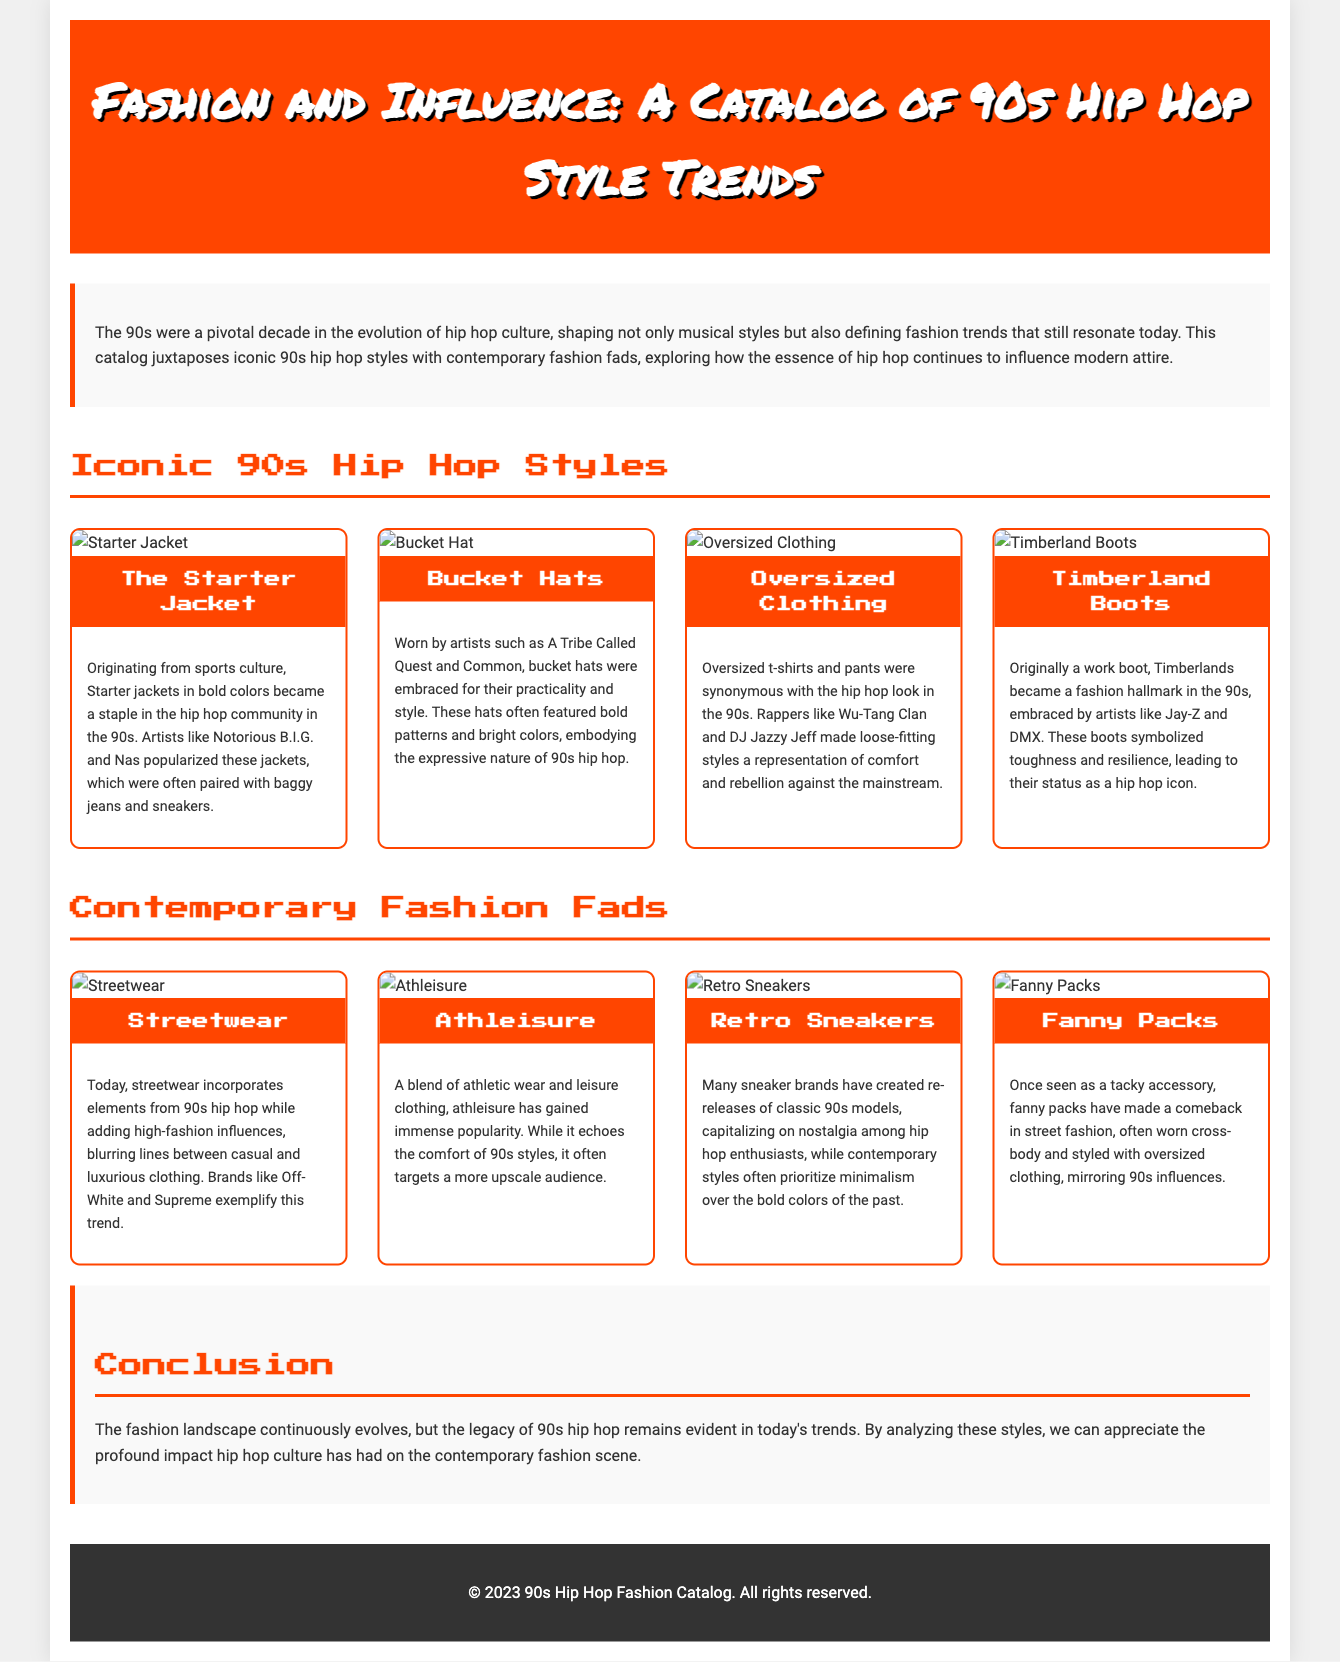What is the title of the catalog? The title of the catalog is prominently displayed in the header section of the document.
Answer: Fashion and Influence: A Catalog of 90s Hip Hop Style Trends Who popularized the Starter Jacket? The document states that certain artists were instrumental in popularizing the Starter Jacket in 90s hip hop culture.
Answer: Notorious B.I.G. and Nas What type of clothing became synonymous with hip hop in the 90s? The catalog describes a specific style of clothing that was widely associated with the hip hop scene during the 90s.
Answer: Oversized Clothing What is a modern equivalent of 90s street fashion? The catalog compares contemporary trends to those of the 90s, identifying a specific modern trend that incorporates those elements.
Answer: Streetwear Which accessory made a comeback in modern street fashion? The document mentions a previously unfashionable accessory that has regained popularity in today's fashion scene.
Answer: Fanny Packs What is a notable characteristic of contemporary athleisure? The catalog provides insight into a modern clothing trend that combines comfort and style, highlighting a specific aspect.
Answer: Upscale audience How many iconic 90s hip hop styles are highlighted in the catalog? The document lists a specific number of styles from the 90s that are compared against contemporary fashion trends.
Answer: Four Which footwear brand was embraced by artists in the 90s? One fashion item is linked to certain artists from the 90s, providing insight into the footwear trend during that time.
Answer: Timberland Boots What feature distinguishes contemporary retro sneakers? The catalog explains how modern sneaker designs relate to 90s styles, focusing on a specific design trend.
Answer: Nostalgia 